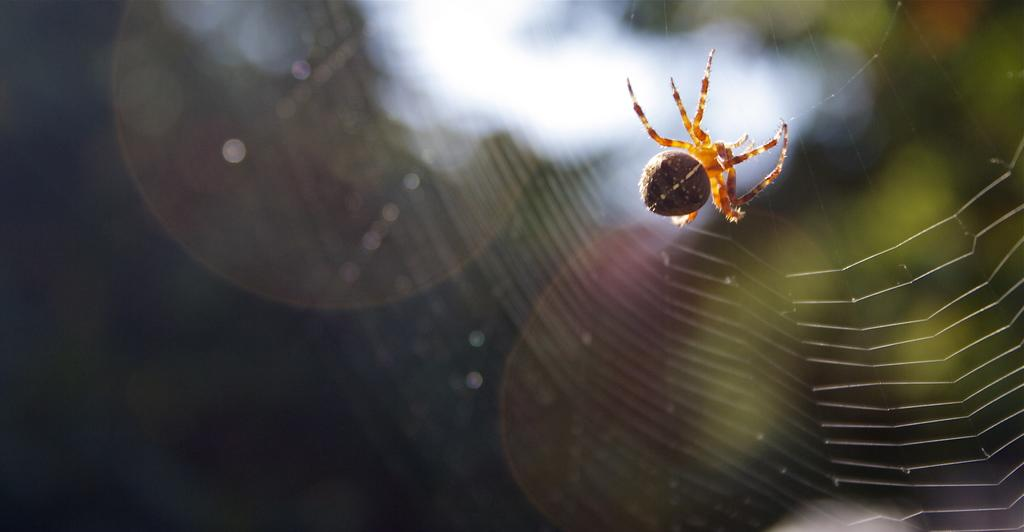What is the main subject of the image? There is a spider in the image. Where is the spider located? The spider is on a spider web. Which side of the image is the spider web on? The spider web is on the right side of the image. How would you describe the background of the image? The background of the image is blurry. Can you identify any objects in the background? Yes, there are objects in the background of the image. What type of crate is visible in the image? There is no crate present in the image. What activities are taking place during the afternoon in the image? The image does not depict any specific time of day or activities related to the afternoon. 